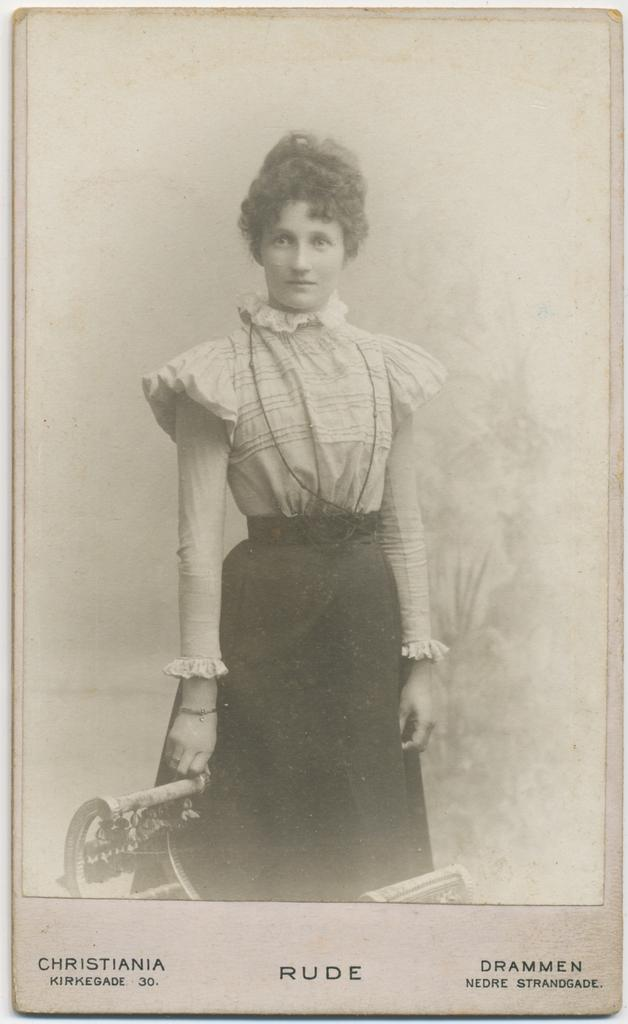What is the main subject of the image? The main subject of the image is a woman standing. Can you describe any additional features or elements in the image? Yes, there is text at the bottom of the woman in the image. What type of fang can be seen in the image? There is no fang present in the image; it features a woman standing with text at the bottom. 